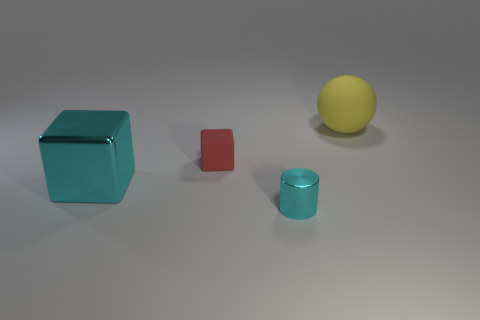How many other objects are the same size as the yellow thing?
Make the answer very short. 1. What is the size of the metal object that is the same shape as the small rubber thing?
Ensure brevity in your answer.  Large. What is the shape of the rubber thing that is in front of the big yellow object?
Offer a terse response. Cube. What is the color of the metallic object that is left of the shiny object on the right side of the large metal block?
Ensure brevity in your answer.  Cyan. What number of objects are either matte objects in front of the large rubber object or balls?
Your response must be concise. 2. Is the size of the red thing the same as the cyan thing that is right of the tiny red cube?
Offer a very short reply. Yes. How many tiny things are shiny objects or objects?
Make the answer very short. 2. There is a large metal thing; what shape is it?
Make the answer very short. Cube. What size is the metal object that is the same color as the shiny cylinder?
Your answer should be compact. Large. Is there a large object made of the same material as the big yellow sphere?
Make the answer very short. No. 